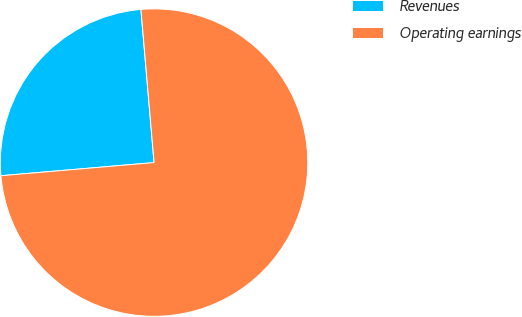Convert chart. <chart><loc_0><loc_0><loc_500><loc_500><pie_chart><fcel>Revenues<fcel>Operating earnings<nl><fcel>25.0%<fcel>75.0%<nl></chart> 